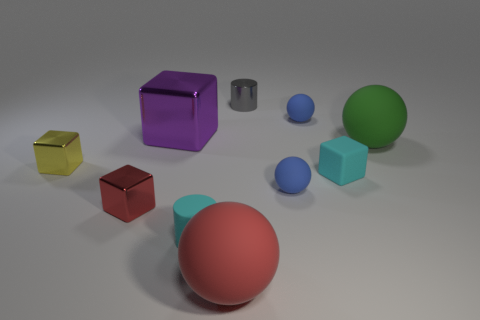How many objects are the same size as the purple metal cube?
Offer a terse response. 2. There is a object that is both to the left of the tiny cyan matte cylinder and behind the big green thing; what is its material?
Give a very brief answer. Metal. There is another cylinder that is the same size as the gray cylinder; what is its material?
Make the answer very short. Rubber. There is a purple shiny object that is on the left side of the small cylinder right of the cyan rubber object left of the red matte sphere; what size is it?
Offer a very short reply. Large. There is a red thing that is the same material as the big purple block; what size is it?
Your answer should be very brief. Small. Do the cyan rubber block and the ball that is in front of the red metallic cube have the same size?
Keep it short and to the point. No. The small cyan rubber object in front of the small matte block has what shape?
Your answer should be very brief. Cylinder. Is there a small rubber cube right of the tiny cyan object that is left of the blue thing behind the purple thing?
Give a very brief answer. Yes. There is a large thing that is the same shape as the tiny red metal thing; what material is it?
Provide a succinct answer. Metal. Are there any other things that have the same material as the red cube?
Your answer should be very brief. Yes. 